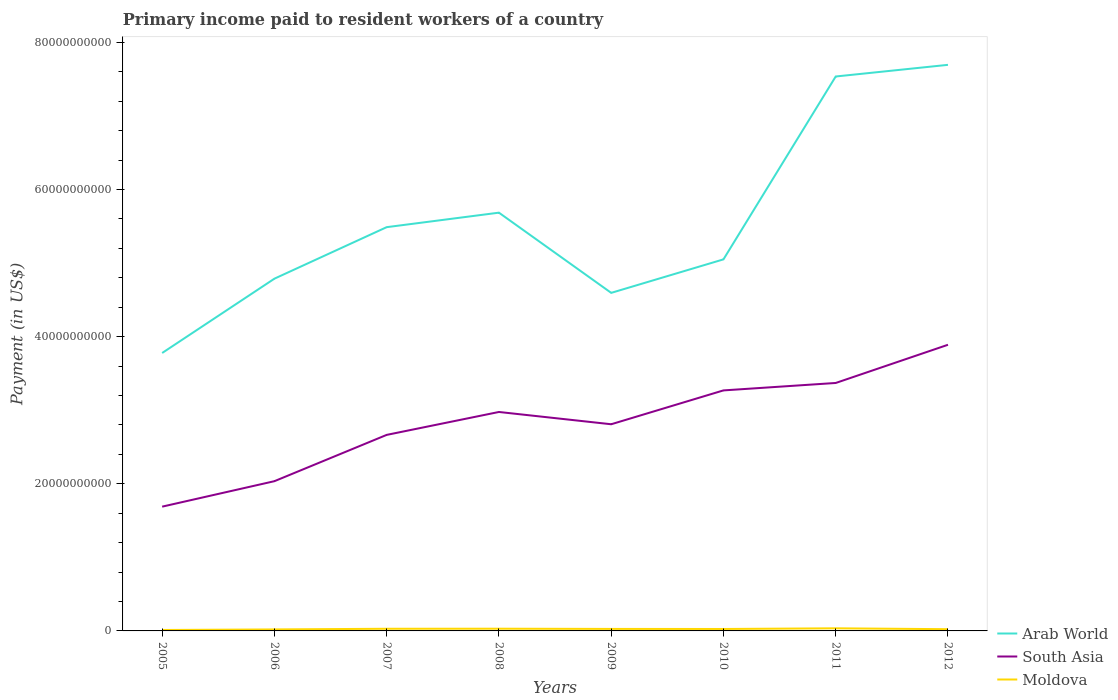Across all years, what is the maximum amount paid to workers in South Asia?
Your answer should be very brief. 1.69e+1. What is the total amount paid to workers in Moldova in the graph?
Offer a terse response. -1.65e+08. What is the difference between the highest and the second highest amount paid to workers in Arab World?
Ensure brevity in your answer.  3.92e+1. Is the amount paid to workers in Moldova strictly greater than the amount paid to workers in South Asia over the years?
Your answer should be very brief. Yes. How many lines are there?
Give a very brief answer. 3. Where does the legend appear in the graph?
Give a very brief answer. Bottom right. How many legend labels are there?
Offer a terse response. 3. What is the title of the graph?
Give a very brief answer. Primary income paid to resident workers of a country. Does "Senegal" appear as one of the legend labels in the graph?
Provide a succinct answer. No. What is the label or title of the Y-axis?
Make the answer very short. Payment (in US$). What is the Payment (in US$) of Arab World in 2005?
Provide a short and direct response. 3.78e+1. What is the Payment (in US$) in South Asia in 2005?
Provide a short and direct response. 1.69e+1. What is the Payment (in US$) of Moldova in 2005?
Your answer should be very brief. 1.28e+08. What is the Payment (in US$) of Arab World in 2006?
Provide a short and direct response. 4.79e+1. What is the Payment (in US$) in South Asia in 2006?
Your answer should be very brief. 2.04e+1. What is the Payment (in US$) of Moldova in 2006?
Give a very brief answer. 2.03e+08. What is the Payment (in US$) of Arab World in 2007?
Provide a succinct answer. 5.49e+1. What is the Payment (in US$) of South Asia in 2007?
Offer a terse response. 2.66e+1. What is the Payment (in US$) in Moldova in 2007?
Offer a terse response. 2.94e+08. What is the Payment (in US$) in Arab World in 2008?
Your response must be concise. 5.68e+1. What is the Payment (in US$) of South Asia in 2008?
Your response must be concise. 2.98e+1. What is the Payment (in US$) of Moldova in 2008?
Your answer should be compact. 3.01e+08. What is the Payment (in US$) of Arab World in 2009?
Your response must be concise. 4.59e+1. What is the Payment (in US$) in South Asia in 2009?
Your answer should be compact. 2.81e+1. What is the Payment (in US$) in Moldova in 2009?
Offer a terse response. 2.71e+08. What is the Payment (in US$) in Arab World in 2010?
Ensure brevity in your answer.  5.05e+1. What is the Payment (in US$) in South Asia in 2010?
Give a very brief answer. 3.27e+1. What is the Payment (in US$) of Moldova in 2010?
Keep it short and to the point. 2.62e+08. What is the Payment (in US$) in Arab World in 2011?
Offer a terse response. 7.54e+1. What is the Payment (in US$) in South Asia in 2011?
Ensure brevity in your answer.  3.37e+1. What is the Payment (in US$) of Moldova in 2011?
Offer a very short reply. 3.55e+08. What is the Payment (in US$) of Arab World in 2012?
Keep it short and to the point. 7.69e+1. What is the Payment (in US$) in South Asia in 2012?
Your response must be concise. 3.89e+1. What is the Payment (in US$) in Moldova in 2012?
Keep it short and to the point. 2.35e+08. Across all years, what is the maximum Payment (in US$) in Arab World?
Provide a short and direct response. 7.69e+1. Across all years, what is the maximum Payment (in US$) in South Asia?
Make the answer very short. 3.89e+1. Across all years, what is the maximum Payment (in US$) of Moldova?
Provide a succinct answer. 3.55e+08. Across all years, what is the minimum Payment (in US$) of Arab World?
Your response must be concise. 3.78e+1. Across all years, what is the minimum Payment (in US$) of South Asia?
Provide a short and direct response. 1.69e+1. Across all years, what is the minimum Payment (in US$) in Moldova?
Your answer should be compact. 1.28e+08. What is the total Payment (in US$) of Arab World in the graph?
Give a very brief answer. 4.46e+11. What is the total Payment (in US$) in South Asia in the graph?
Your answer should be very brief. 2.27e+11. What is the total Payment (in US$) in Moldova in the graph?
Give a very brief answer. 2.05e+09. What is the difference between the Payment (in US$) in Arab World in 2005 and that in 2006?
Offer a terse response. -1.01e+1. What is the difference between the Payment (in US$) in South Asia in 2005 and that in 2006?
Provide a succinct answer. -3.46e+09. What is the difference between the Payment (in US$) of Moldova in 2005 and that in 2006?
Make the answer very short. -7.50e+07. What is the difference between the Payment (in US$) of Arab World in 2005 and that in 2007?
Your answer should be very brief. -1.71e+1. What is the difference between the Payment (in US$) of South Asia in 2005 and that in 2007?
Provide a short and direct response. -9.75e+09. What is the difference between the Payment (in US$) of Moldova in 2005 and that in 2007?
Offer a terse response. -1.65e+08. What is the difference between the Payment (in US$) of Arab World in 2005 and that in 2008?
Give a very brief answer. -1.91e+1. What is the difference between the Payment (in US$) of South Asia in 2005 and that in 2008?
Keep it short and to the point. -1.29e+1. What is the difference between the Payment (in US$) in Moldova in 2005 and that in 2008?
Offer a terse response. -1.73e+08. What is the difference between the Payment (in US$) of Arab World in 2005 and that in 2009?
Your response must be concise. -8.17e+09. What is the difference between the Payment (in US$) in South Asia in 2005 and that in 2009?
Offer a terse response. -1.12e+1. What is the difference between the Payment (in US$) of Moldova in 2005 and that in 2009?
Your answer should be very brief. -1.42e+08. What is the difference between the Payment (in US$) in Arab World in 2005 and that in 2010?
Your answer should be very brief. -1.27e+1. What is the difference between the Payment (in US$) of South Asia in 2005 and that in 2010?
Offer a terse response. -1.58e+1. What is the difference between the Payment (in US$) in Moldova in 2005 and that in 2010?
Keep it short and to the point. -1.34e+08. What is the difference between the Payment (in US$) of Arab World in 2005 and that in 2011?
Provide a short and direct response. -3.76e+1. What is the difference between the Payment (in US$) of South Asia in 2005 and that in 2011?
Give a very brief answer. -1.68e+1. What is the difference between the Payment (in US$) in Moldova in 2005 and that in 2011?
Your answer should be compact. -2.27e+08. What is the difference between the Payment (in US$) of Arab World in 2005 and that in 2012?
Give a very brief answer. -3.92e+1. What is the difference between the Payment (in US$) of South Asia in 2005 and that in 2012?
Keep it short and to the point. -2.20e+1. What is the difference between the Payment (in US$) in Moldova in 2005 and that in 2012?
Provide a short and direct response. -1.07e+08. What is the difference between the Payment (in US$) of Arab World in 2006 and that in 2007?
Make the answer very short. -7.00e+09. What is the difference between the Payment (in US$) in South Asia in 2006 and that in 2007?
Your answer should be compact. -6.29e+09. What is the difference between the Payment (in US$) in Moldova in 2006 and that in 2007?
Make the answer very short. -9.03e+07. What is the difference between the Payment (in US$) of Arab World in 2006 and that in 2008?
Your answer should be compact. -8.97e+09. What is the difference between the Payment (in US$) of South Asia in 2006 and that in 2008?
Provide a succinct answer. -9.41e+09. What is the difference between the Payment (in US$) of Moldova in 2006 and that in 2008?
Provide a short and direct response. -9.80e+07. What is the difference between the Payment (in US$) of Arab World in 2006 and that in 2009?
Keep it short and to the point. 1.93e+09. What is the difference between the Payment (in US$) of South Asia in 2006 and that in 2009?
Provide a succinct answer. -7.74e+09. What is the difference between the Payment (in US$) of Moldova in 2006 and that in 2009?
Your answer should be compact. -6.74e+07. What is the difference between the Payment (in US$) in Arab World in 2006 and that in 2010?
Keep it short and to the point. -2.62e+09. What is the difference between the Payment (in US$) of South Asia in 2006 and that in 2010?
Provide a short and direct response. -1.23e+1. What is the difference between the Payment (in US$) of Moldova in 2006 and that in 2010?
Make the answer very short. -5.89e+07. What is the difference between the Payment (in US$) of Arab World in 2006 and that in 2011?
Your response must be concise. -2.75e+1. What is the difference between the Payment (in US$) of South Asia in 2006 and that in 2011?
Offer a very short reply. -1.33e+1. What is the difference between the Payment (in US$) of Moldova in 2006 and that in 2011?
Offer a very short reply. -1.52e+08. What is the difference between the Payment (in US$) of Arab World in 2006 and that in 2012?
Offer a very short reply. -2.91e+1. What is the difference between the Payment (in US$) in South Asia in 2006 and that in 2012?
Provide a succinct answer. -1.85e+1. What is the difference between the Payment (in US$) of Moldova in 2006 and that in 2012?
Give a very brief answer. -3.18e+07. What is the difference between the Payment (in US$) in Arab World in 2007 and that in 2008?
Ensure brevity in your answer.  -1.97e+09. What is the difference between the Payment (in US$) of South Asia in 2007 and that in 2008?
Keep it short and to the point. -3.11e+09. What is the difference between the Payment (in US$) of Moldova in 2007 and that in 2008?
Your answer should be compact. -7.77e+06. What is the difference between the Payment (in US$) of Arab World in 2007 and that in 2009?
Your answer should be very brief. 8.93e+09. What is the difference between the Payment (in US$) of South Asia in 2007 and that in 2009?
Ensure brevity in your answer.  -1.45e+09. What is the difference between the Payment (in US$) in Moldova in 2007 and that in 2009?
Ensure brevity in your answer.  2.28e+07. What is the difference between the Payment (in US$) of Arab World in 2007 and that in 2010?
Offer a very short reply. 4.38e+09. What is the difference between the Payment (in US$) in South Asia in 2007 and that in 2010?
Keep it short and to the point. -6.05e+09. What is the difference between the Payment (in US$) in Moldova in 2007 and that in 2010?
Provide a short and direct response. 3.14e+07. What is the difference between the Payment (in US$) in Arab World in 2007 and that in 2011?
Keep it short and to the point. -2.05e+1. What is the difference between the Payment (in US$) of South Asia in 2007 and that in 2011?
Ensure brevity in your answer.  -7.06e+09. What is the difference between the Payment (in US$) in Moldova in 2007 and that in 2011?
Ensure brevity in your answer.  -6.16e+07. What is the difference between the Payment (in US$) in Arab World in 2007 and that in 2012?
Your response must be concise. -2.21e+1. What is the difference between the Payment (in US$) in South Asia in 2007 and that in 2012?
Provide a succinct answer. -1.22e+1. What is the difference between the Payment (in US$) in Moldova in 2007 and that in 2012?
Your answer should be compact. 5.85e+07. What is the difference between the Payment (in US$) of Arab World in 2008 and that in 2009?
Your answer should be very brief. 1.09e+1. What is the difference between the Payment (in US$) of South Asia in 2008 and that in 2009?
Give a very brief answer. 1.67e+09. What is the difference between the Payment (in US$) of Moldova in 2008 and that in 2009?
Provide a short and direct response. 3.06e+07. What is the difference between the Payment (in US$) in Arab World in 2008 and that in 2010?
Provide a succinct answer. 6.35e+09. What is the difference between the Payment (in US$) of South Asia in 2008 and that in 2010?
Provide a short and direct response. -2.93e+09. What is the difference between the Payment (in US$) of Moldova in 2008 and that in 2010?
Make the answer very short. 3.92e+07. What is the difference between the Payment (in US$) of Arab World in 2008 and that in 2011?
Provide a short and direct response. -1.85e+1. What is the difference between the Payment (in US$) in South Asia in 2008 and that in 2011?
Give a very brief answer. -3.94e+09. What is the difference between the Payment (in US$) of Moldova in 2008 and that in 2011?
Offer a terse response. -5.38e+07. What is the difference between the Payment (in US$) of Arab World in 2008 and that in 2012?
Offer a very short reply. -2.01e+1. What is the difference between the Payment (in US$) of South Asia in 2008 and that in 2012?
Ensure brevity in your answer.  -9.13e+09. What is the difference between the Payment (in US$) of Moldova in 2008 and that in 2012?
Ensure brevity in your answer.  6.63e+07. What is the difference between the Payment (in US$) of Arab World in 2009 and that in 2010?
Keep it short and to the point. -4.55e+09. What is the difference between the Payment (in US$) in South Asia in 2009 and that in 2010?
Ensure brevity in your answer.  -4.60e+09. What is the difference between the Payment (in US$) in Moldova in 2009 and that in 2010?
Give a very brief answer. 8.54e+06. What is the difference between the Payment (in US$) in Arab World in 2009 and that in 2011?
Offer a terse response. -2.94e+1. What is the difference between the Payment (in US$) of South Asia in 2009 and that in 2011?
Your response must be concise. -5.61e+09. What is the difference between the Payment (in US$) in Moldova in 2009 and that in 2011?
Keep it short and to the point. -8.44e+07. What is the difference between the Payment (in US$) in Arab World in 2009 and that in 2012?
Make the answer very short. -3.10e+1. What is the difference between the Payment (in US$) in South Asia in 2009 and that in 2012?
Your answer should be compact. -1.08e+1. What is the difference between the Payment (in US$) of Moldova in 2009 and that in 2012?
Offer a very short reply. 3.57e+07. What is the difference between the Payment (in US$) in Arab World in 2010 and that in 2011?
Your answer should be compact. -2.49e+1. What is the difference between the Payment (in US$) of South Asia in 2010 and that in 2011?
Your response must be concise. -1.01e+09. What is the difference between the Payment (in US$) in Moldova in 2010 and that in 2011?
Provide a succinct answer. -9.30e+07. What is the difference between the Payment (in US$) in Arab World in 2010 and that in 2012?
Provide a short and direct response. -2.64e+1. What is the difference between the Payment (in US$) in South Asia in 2010 and that in 2012?
Keep it short and to the point. -6.20e+09. What is the difference between the Payment (in US$) of Moldova in 2010 and that in 2012?
Offer a very short reply. 2.72e+07. What is the difference between the Payment (in US$) in Arab World in 2011 and that in 2012?
Your answer should be very brief. -1.58e+09. What is the difference between the Payment (in US$) in South Asia in 2011 and that in 2012?
Keep it short and to the point. -5.19e+09. What is the difference between the Payment (in US$) in Moldova in 2011 and that in 2012?
Your response must be concise. 1.20e+08. What is the difference between the Payment (in US$) in Arab World in 2005 and the Payment (in US$) in South Asia in 2006?
Keep it short and to the point. 1.74e+1. What is the difference between the Payment (in US$) in Arab World in 2005 and the Payment (in US$) in Moldova in 2006?
Make the answer very short. 3.76e+1. What is the difference between the Payment (in US$) in South Asia in 2005 and the Payment (in US$) in Moldova in 2006?
Offer a terse response. 1.67e+1. What is the difference between the Payment (in US$) in Arab World in 2005 and the Payment (in US$) in South Asia in 2007?
Your response must be concise. 1.11e+1. What is the difference between the Payment (in US$) of Arab World in 2005 and the Payment (in US$) of Moldova in 2007?
Offer a very short reply. 3.75e+1. What is the difference between the Payment (in US$) of South Asia in 2005 and the Payment (in US$) of Moldova in 2007?
Provide a short and direct response. 1.66e+1. What is the difference between the Payment (in US$) in Arab World in 2005 and the Payment (in US$) in South Asia in 2008?
Offer a very short reply. 8.02e+09. What is the difference between the Payment (in US$) of Arab World in 2005 and the Payment (in US$) of Moldova in 2008?
Offer a terse response. 3.75e+1. What is the difference between the Payment (in US$) of South Asia in 2005 and the Payment (in US$) of Moldova in 2008?
Your answer should be very brief. 1.66e+1. What is the difference between the Payment (in US$) in Arab World in 2005 and the Payment (in US$) in South Asia in 2009?
Your response must be concise. 9.68e+09. What is the difference between the Payment (in US$) of Arab World in 2005 and the Payment (in US$) of Moldova in 2009?
Your response must be concise. 3.75e+1. What is the difference between the Payment (in US$) in South Asia in 2005 and the Payment (in US$) in Moldova in 2009?
Your answer should be compact. 1.66e+1. What is the difference between the Payment (in US$) of Arab World in 2005 and the Payment (in US$) of South Asia in 2010?
Provide a short and direct response. 5.08e+09. What is the difference between the Payment (in US$) of Arab World in 2005 and the Payment (in US$) of Moldova in 2010?
Give a very brief answer. 3.75e+1. What is the difference between the Payment (in US$) of South Asia in 2005 and the Payment (in US$) of Moldova in 2010?
Keep it short and to the point. 1.66e+1. What is the difference between the Payment (in US$) of Arab World in 2005 and the Payment (in US$) of South Asia in 2011?
Your answer should be very brief. 4.07e+09. What is the difference between the Payment (in US$) in Arab World in 2005 and the Payment (in US$) in Moldova in 2011?
Your answer should be compact. 3.74e+1. What is the difference between the Payment (in US$) in South Asia in 2005 and the Payment (in US$) in Moldova in 2011?
Provide a succinct answer. 1.65e+1. What is the difference between the Payment (in US$) of Arab World in 2005 and the Payment (in US$) of South Asia in 2012?
Make the answer very short. -1.12e+09. What is the difference between the Payment (in US$) of Arab World in 2005 and the Payment (in US$) of Moldova in 2012?
Provide a succinct answer. 3.75e+1. What is the difference between the Payment (in US$) in South Asia in 2005 and the Payment (in US$) in Moldova in 2012?
Offer a very short reply. 1.67e+1. What is the difference between the Payment (in US$) in Arab World in 2006 and the Payment (in US$) in South Asia in 2007?
Offer a terse response. 2.12e+1. What is the difference between the Payment (in US$) in Arab World in 2006 and the Payment (in US$) in Moldova in 2007?
Offer a very short reply. 4.76e+1. What is the difference between the Payment (in US$) in South Asia in 2006 and the Payment (in US$) in Moldova in 2007?
Keep it short and to the point. 2.01e+1. What is the difference between the Payment (in US$) in Arab World in 2006 and the Payment (in US$) in South Asia in 2008?
Provide a succinct answer. 1.81e+1. What is the difference between the Payment (in US$) of Arab World in 2006 and the Payment (in US$) of Moldova in 2008?
Make the answer very short. 4.76e+1. What is the difference between the Payment (in US$) of South Asia in 2006 and the Payment (in US$) of Moldova in 2008?
Offer a terse response. 2.00e+1. What is the difference between the Payment (in US$) in Arab World in 2006 and the Payment (in US$) in South Asia in 2009?
Your answer should be very brief. 1.98e+1. What is the difference between the Payment (in US$) in Arab World in 2006 and the Payment (in US$) in Moldova in 2009?
Keep it short and to the point. 4.76e+1. What is the difference between the Payment (in US$) of South Asia in 2006 and the Payment (in US$) of Moldova in 2009?
Offer a terse response. 2.01e+1. What is the difference between the Payment (in US$) of Arab World in 2006 and the Payment (in US$) of South Asia in 2010?
Your answer should be very brief. 1.52e+1. What is the difference between the Payment (in US$) of Arab World in 2006 and the Payment (in US$) of Moldova in 2010?
Keep it short and to the point. 4.76e+1. What is the difference between the Payment (in US$) in South Asia in 2006 and the Payment (in US$) in Moldova in 2010?
Keep it short and to the point. 2.01e+1. What is the difference between the Payment (in US$) of Arab World in 2006 and the Payment (in US$) of South Asia in 2011?
Provide a short and direct response. 1.42e+1. What is the difference between the Payment (in US$) in Arab World in 2006 and the Payment (in US$) in Moldova in 2011?
Your answer should be very brief. 4.75e+1. What is the difference between the Payment (in US$) of South Asia in 2006 and the Payment (in US$) of Moldova in 2011?
Keep it short and to the point. 2.00e+1. What is the difference between the Payment (in US$) in Arab World in 2006 and the Payment (in US$) in South Asia in 2012?
Your answer should be compact. 8.98e+09. What is the difference between the Payment (in US$) of Arab World in 2006 and the Payment (in US$) of Moldova in 2012?
Ensure brevity in your answer.  4.76e+1. What is the difference between the Payment (in US$) of South Asia in 2006 and the Payment (in US$) of Moldova in 2012?
Provide a succinct answer. 2.01e+1. What is the difference between the Payment (in US$) in Arab World in 2007 and the Payment (in US$) in South Asia in 2008?
Provide a short and direct response. 2.51e+1. What is the difference between the Payment (in US$) in Arab World in 2007 and the Payment (in US$) in Moldova in 2008?
Your response must be concise. 5.46e+1. What is the difference between the Payment (in US$) of South Asia in 2007 and the Payment (in US$) of Moldova in 2008?
Your answer should be compact. 2.63e+1. What is the difference between the Payment (in US$) in Arab World in 2007 and the Payment (in US$) in South Asia in 2009?
Offer a very short reply. 2.68e+1. What is the difference between the Payment (in US$) in Arab World in 2007 and the Payment (in US$) in Moldova in 2009?
Provide a short and direct response. 5.46e+1. What is the difference between the Payment (in US$) of South Asia in 2007 and the Payment (in US$) of Moldova in 2009?
Keep it short and to the point. 2.64e+1. What is the difference between the Payment (in US$) of Arab World in 2007 and the Payment (in US$) of South Asia in 2010?
Make the answer very short. 2.22e+1. What is the difference between the Payment (in US$) of Arab World in 2007 and the Payment (in US$) of Moldova in 2010?
Your answer should be very brief. 5.46e+1. What is the difference between the Payment (in US$) of South Asia in 2007 and the Payment (in US$) of Moldova in 2010?
Your answer should be very brief. 2.64e+1. What is the difference between the Payment (in US$) in Arab World in 2007 and the Payment (in US$) in South Asia in 2011?
Provide a succinct answer. 2.12e+1. What is the difference between the Payment (in US$) in Arab World in 2007 and the Payment (in US$) in Moldova in 2011?
Ensure brevity in your answer.  5.45e+1. What is the difference between the Payment (in US$) of South Asia in 2007 and the Payment (in US$) of Moldova in 2011?
Ensure brevity in your answer.  2.63e+1. What is the difference between the Payment (in US$) in Arab World in 2007 and the Payment (in US$) in South Asia in 2012?
Ensure brevity in your answer.  1.60e+1. What is the difference between the Payment (in US$) of Arab World in 2007 and the Payment (in US$) of Moldova in 2012?
Keep it short and to the point. 5.46e+1. What is the difference between the Payment (in US$) of South Asia in 2007 and the Payment (in US$) of Moldova in 2012?
Give a very brief answer. 2.64e+1. What is the difference between the Payment (in US$) of Arab World in 2008 and the Payment (in US$) of South Asia in 2009?
Ensure brevity in your answer.  2.88e+1. What is the difference between the Payment (in US$) in Arab World in 2008 and the Payment (in US$) in Moldova in 2009?
Offer a terse response. 5.66e+1. What is the difference between the Payment (in US$) in South Asia in 2008 and the Payment (in US$) in Moldova in 2009?
Ensure brevity in your answer.  2.95e+1. What is the difference between the Payment (in US$) of Arab World in 2008 and the Payment (in US$) of South Asia in 2010?
Your response must be concise. 2.42e+1. What is the difference between the Payment (in US$) of Arab World in 2008 and the Payment (in US$) of Moldova in 2010?
Offer a very short reply. 5.66e+1. What is the difference between the Payment (in US$) of South Asia in 2008 and the Payment (in US$) of Moldova in 2010?
Your answer should be compact. 2.95e+1. What is the difference between the Payment (in US$) of Arab World in 2008 and the Payment (in US$) of South Asia in 2011?
Your response must be concise. 2.31e+1. What is the difference between the Payment (in US$) of Arab World in 2008 and the Payment (in US$) of Moldova in 2011?
Offer a terse response. 5.65e+1. What is the difference between the Payment (in US$) of South Asia in 2008 and the Payment (in US$) of Moldova in 2011?
Make the answer very short. 2.94e+1. What is the difference between the Payment (in US$) of Arab World in 2008 and the Payment (in US$) of South Asia in 2012?
Your answer should be compact. 1.80e+1. What is the difference between the Payment (in US$) in Arab World in 2008 and the Payment (in US$) in Moldova in 2012?
Your answer should be compact. 5.66e+1. What is the difference between the Payment (in US$) in South Asia in 2008 and the Payment (in US$) in Moldova in 2012?
Offer a very short reply. 2.95e+1. What is the difference between the Payment (in US$) in Arab World in 2009 and the Payment (in US$) in South Asia in 2010?
Give a very brief answer. 1.33e+1. What is the difference between the Payment (in US$) of Arab World in 2009 and the Payment (in US$) of Moldova in 2010?
Give a very brief answer. 4.57e+1. What is the difference between the Payment (in US$) of South Asia in 2009 and the Payment (in US$) of Moldova in 2010?
Give a very brief answer. 2.78e+1. What is the difference between the Payment (in US$) in Arab World in 2009 and the Payment (in US$) in South Asia in 2011?
Provide a short and direct response. 1.22e+1. What is the difference between the Payment (in US$) in Arab World in 2009 and the Payment (in US$) in Moldova in 2011?
Your response must be concise. 4.56e+1. What is the difference between the Payment (in US$) in South Asia in 2009 and the Payment (in US$) in Moldova in 2011?
Provide a succinct answer. 2.77e+1. What is the difference between the Payment (in US$) in Arab World in 2009 and the Payment (in US$) in South Asia in 2012?
Keep it short and to the point. 7.05e+09. What is the difference between the Payment (in US$) in Arab World in 2009 and the Payment (in US$) in Moldova in 2012?
Your response must be concise. 4.57e+1. What is the difference between the Payment (in US$) of South Asia in 2009 and the Payment (in US$) of Moldova in 2012?
Keep it short and to the point. 2.79e+1. What is the difference between the Payment (in US$) of Arab World in 2010 and the Payment (in US$) of South Asia in 2011?
Keep it short and to the point. 1.68e+1. What is the difference between the Payment (in US$) of Arab World in 2010 and the Payment (in US$) of Moldova in 2011?
Your answer should be very brief. 5.01e+1. What is the difference between the Payment (in US$) of South Asia in 2010 and the Payment (in US$) of Moldova in 2011?
Give a very brief answer. 3.23e+1. What is the difference between the Payment (in US$) of Arab World in 2010 and the Payment (in US$) of South Asia in 2012?
Your answer should be very brief. 1.16e+1. What is the difference between the Payment (in US$) in Arab World in 2010 and the Payment (in US$) in Moldova in 2012?
Offer a terse response. 5.03e+1. What is the difference between the Payment (in US$) of South Asia in 2010 and the Payment (in US$) of Moldova in 2012?
Give a very brief answer. 3.25e+1. What is the difference between the Payment (in US$) in Arab World in 2011 and the Payment (in US$) in South Asia in 2012?
Make the answer very short. 3.65e+1. What is the difference between the Payment (in US$) of Arab World in 2011 and the Payment (in US$) of Moldova in 2012?
Provide a succinct answer. 7.51e+1. What is the difference between the Payment (in US$) in South Asia in 2011 and the Payment (in US$) in Moldova in 2012?
Provide a succinct answer. 3.35e+1. What is the average Payment (in US$) of Arab World per year?
Offer a very short reply. 5.58e+1. What is the average Payment (in US$) of South Asia per year?
Provide a short and direct response. 2.84e+1. What is the average Payment (in US$) in Moldova per year?
Give a very brief answer. 2.56e+08. In the year 2005, what is the difference between the Payment (in US$) of Arab World and Payment (in US$) of South Asia?
Give a very brief answer. 2.09e+1. In the year 2005, what is the difference between the Payment (in US$) of Arab World and Payment (in US$) of Moldova?
Your response must be concise. 3.76e+1. In the year 2005, what is the difference between the Payment (in US$) of South Asia and Payment (in US$) of Moldova?
Give a very brief answer. 1.68e+1. In the year 2006, what is the difference between the Payment (in US$) of Arab World and Payment (in US$) of South Asia?
Make the answer very short. 2.75e+1. In the year 2006, what is the difference between the Payment (in US$) in Arab World and Payment (in US$) in Moldova?
Keep it short and to the point. 4.77e+1. In the year 2006, what is the difference between the Payment (in US$) of South Asia and Payment (in US$) of Moldova?
Make the answer very short. 2.01e+1. In the year 2007, what is the difference between the Payment (in US$) of Arab World and Payment (in US$) of South Asia?
Your answer should be very brief. 2.82e+1. In the year 2007, what is the difference between the Payment (in US$) of Arab World and Payment (in US$) of Moldova?
Offer a very short reply. 5.46e+1. In the year 2007, what is the difference between the Payment (in US$) of South Asia and Payment (in US$) of Moldova?
Keep it short and to the point. 2.63e+1. In the year 2008, what is the difference between the Payment (in US$) in Arab World and Payment (in US$) in South Asia?
Keep it short and to the point. 2.71e+1. In the year 2008, what is the difference between the Payment (in US$) of Arab World and Payment (in US$) of Moldova?
Your answer should be very brief. 5.65e+1. In the year 2008, what is the difference between the Payment (in US$) of South Asia and Payment (in US$) of Moldova?
Your response must be concise. 2.95e+1. In the year 2009, what is the difference between the Payment (in US$) in Arab World and Payment (in US$) in South Asia?
Provide a short and direct response. 1.79e+1. In the year 2009, what is the difference between the Payment (in US$) of Arab World and Payment (in US$) of Moldova?
Give a very brief answer. 4.57e+1. In the year 2009, what is the difference between the Payment (in US$) in South Asia and Payment (in US$) in Moldova?
Give a very brief answer. 2.78e+1. In the year 2010, what is the difference between the Payment (in US$) in Arab World and Payment (in US$) in South Asia?
Provide a short and direct response. 1.78e+1. In the year 2010, what is the difference between the Payment (in US$) of Arab World and Payment (in US$) of Moldova?
Make the answer very short. 5.02e+1. In the year 2010, what is the difference between the Payment (in US$) in South Asia and Payment (in US$) in Moldova?
Your answer should be compact. 3.24e+1. In the year 2011, what is the difference between the Payment (in US$) in Arab World and Payment (in US$) in South Asia?
Your answer should be very brief. 4.17e+1. In the year 2011, what is the difference between the Payment (in US$) in Arab World and Payment (in US$) in Moldova?
Your response must be concise. 7.50e+1. In the year 2011, what is the difference between the Payment (in US$) in South Asia and Payment (in US$) in Moldova?
Ensure brevity in your answer.  3.33e+1. In the year 2012, what is the difference between the Payment (in US$) of Arab World and Payment (in US$) of South Asia?
Provide a short and direct response. 3.80e+1. In the year 2012, what is the difference between the Payment (in US$) in Arab World and Payment (in US$) in Moldova?
Provide a succinct answer. 7.67e+1. In the year 2012, what is the difference between the Payment (in US$) of South Asia and Payment (in US$) of Moldova?
Your answer should be compact. 3.87e+1. What is the ratio of the Payment (in US$) in Arab World in 2005 to that in 2006?
Your answer should be very brief. 0.79. What is the ratio of the Payment (in US$) in South Asia in 2005 to that in 2006?
Give a very brief answer. 0.83. What is the ratio of the Payment (in US$) in Moldova in 2005 to that in 2006?
Your answer should be compact. 0.63. What is the ratio of the Payment (in US$) in Arab World in 2005 to that in 2007?
Provide a succinct answer. 0.69. What is the ratio of the Payment (in US$) of South Asia in 2005 to that in 2007?
Ensure brevity in your answer.  0.63. What is the ratio of the Payment (in US$) in Moldova in 2005 to that in 2007?
Make the answer very short. 0.44. What is the ratio of the Payment (in US$) of Arab World in 2005 to that in 2008?
Give a very brief answer. 0.66. What is the ratio of the Payment (in US$) of South Asia in 2005 to that in 2008?
Your answer should be compact. 0.57. What is the ratio of the Payment (in US$) in Moldova in 2005 to that in 2008?
Your answer should be compact. 0.43. What is the ratio of the Payment (in US$) of Arab World in 2005 to that in 2009?
Offer a very short reply. 0.82. What is the ratio of the Payment (in US$) in South Asia in 2005 to that in 2009?
Your answer should be compact. 0.6. What is the ratio of the Payment (in US$) in Moldova in 2005 to that in 2009?
Provide a succinct answer. 0.47. What is the ratio of the Payment (in US$) in Arab World in 2005 to that in 2010?
Your answer should be very brief. 0.75. What is the ratio of the Payment (in US$) of South Asia in 2005 to that in 2010?
Ensure brevity in your answer.  0.52. What is the ratio of the Payment (in US$) in Moldova in 2005 to that in 2010?
Make the answer very short. 0.49. What is the ratio of the Payment (in US$) of Arab World in 2005 to that in 2011?
Give a very brief answer. 0.5. What is the ratio of the Payment (in US$) in South Asia in 2005 to that in 2011?
Your response must be concise. 0.5. What is the ratio of the Payment (in US$) of Moldova in 2005 to that in 2011?
Keep it short and to the point. 0.36. What is the ratio of the Payment (in US$) of Arab World in 2005 to that in 2012?
Offer a very short reply. 0.49. What is the ratio of the Payment (in US$) of South Asia in 2005 to that in 2012?
Keep it short and to the point. 0.43. What is the ratio of the Payment (in US$) of Moldova in 2005 to that in 2012?
Provide a short and direct response. 0.55. What is the ratio of the Payment (in US$) of Arab World in 2006 to that in 2007?
Provide a short and direct response. 0.87. What is the ratio of the Payment (in US$) of South Asia in 2006 to that in 2007?
Provide a succinct answer. 0.76. What is the ratio of the Payment (in US$) in Moldova in 2006 to that in 2007?
Your response must be concise. 0.69. What is the ratio of the Payment (in US$) of Arab World in 2006 to that in 2008?
Ensure brevity in your answer.  0.84. What is the ratio of the Payment (in US$) of South Asia in 2006 to that in 2008?
Offer a terse response. 0.68. What is the ratio of the Payment (in US$) in Moldova in 2006 to that in 2008?
Your answer should be compact. 0.67. What is the ratio of the Payment (in US$) in Arab World in 2006 to that in 2009?
Provide a succinct answer. 1.04. What is the ratio of the Payment (in US$) of South Asia in 2006 to that in 2009?
Provide a succinct answer. 0.72. What is the ratio of the Payment (in US$) of Moldova in 2006 to that in 2009?
Offer a very short reply. 0.75. What is the ratio of the Payment (in US$) of Arab World in 2006 to that in 2010?
Offer a very short reply. 0.95. What is the ratio of the Payment (in US$) in South Asia in 2006 to that in 2010?
Provide a short and direct response. 0.62. What is the ratio of the Payment (in US$) of Moldova in 2006 to that in 2010?
Keep it short and to the point. 0.78. What is the ratio of the Payment (in US$) of Arab World in 2006 to that in 2011?
Provide a succinct answer. 0.64. What is the ratio of the Payment (in US$) in South Asia in 2006 to that in 2011?
Your answer should be very brief. 0.6. What is the ratio of the Payment (in US$) in Moldova in 2006 to that in 2011?
Your answer should be very brief. 0.57. What is the ratio of the Payment (in US$) of Arab World in 2006 to that in 2012?
Ensure brevity in your answer.  0.62. What is the ratio of the Payment (in US$) in South Asia in 2006 to that in 2012?
Give a very brief answer. 0.52. What is the ratio of the Payment (in US$) of Moldova in 2006 to that in 2012?
Keep it short and to the point. 0.86. What is the ratio of the Payment (in US$) in Arab World in 2007 to that in 2008?
Offer a terse response. 0.97. What is the ratio of the Payment (in US$) in South Asia in 2007 to that in 2008?
Offer a very short reply. 0.9. What is the ratio of the Payment (in US$) in Moldova in 2007 to that in 2008?
Provide a short and direct response. 0.97. What is the ratio of the Payment (in US$) in Arab World in 2007 to that in 2009?
Give a very brief answer. 1.19. What is the ratio of the Payment (in US$) of South Asia in 2007 to that in 2009?
Ensure brevity in your answer.  0.95. What is the ratio of the Payment (in US$) of Moldova in 2007 to that in 2009?
Offer a terse response. 1.08. What is the ratio of the Payment (in US$) of Arab World in 2007 to that in 2010?
Provide a short and direct response. 1.09. What is the ratio of the Payment (in US$) of South Asia in 2007 to that in 2010?
Your answer should be very brief. 0.81. What is the ratio of the Payment (in US$) of Moldova in 2007 to that in 2010?
Your answer should be very brief. 1.12. What is the ratio of the Payment (in US$) of Arab World in 2007 to that in 2011?
Your answer should be compact. 0.73. What is the ratio of the Payment (in US$) of South Asia in 2007 to that in 2011?
Your answer should be compact. 0.79. What is the ratio of the Payment (in US$) in Moldova in 2007 to that in 2011?
Keep it short and to the point. 0.83. What is the ratio of the Payment (in US$) in Arab World in 2007 to that in 2012?
Your answer should be compact. 0.71. What is the ratio of the Payment (in US$) in South Asia in 2007 to that in 2012?
Keep it short and to the point. 0.69. What is the ratio of the Payment (in US$) in Moldova in 2007 to that in 2012?
Offer a very short reply. 1.25. What is the ratio of the Payment (in US$) of Arab World in 2008 to that in 2009?
Make the answer very short. 1.24. What is the ratio of the Payment (in US$) of South Asia in 2008 to that in 2009?
Your response must be concise. 1.06. What is the ratio of the Payment (in US$) in Moldova in 2008 to that in 2009?
Make the answer very short. 1.11. What is the ratio of the Payment (in US$) in Arab World in 2008 to that in 2010?
Your answer should be very brief. 1.13. What is the ratio of the Payment (in US$) in South Asia in 2008 to that in 2010?
Ensure brevity in your answer.  0.91. What is the ratio of the Payment (in US$) of Moldova in 2008 to that in 2010?
Provide a succinct answer. 1.15. What is the ratio of the Payment (in US$) in Arab World in 2008 to that in 2011?
Your answer should be very brief. 0.75. What is the ratio of the Payment (in US$) in South Asia in 2008 to that in 2011?
Give a very brief answer. 0.88. What is the ratio of the Payment (in US$) in Moldova in 2008 to that in 2011?
Your answer should be compact. 0.85. What is the ratio of the Payment (in US$) in Arab World in 2008 to that in 2012?
Your answer should be very brief. 0.74. What is the ratio of the Payment (in US$) in South Asia in 2008 to that in 2012?
Offer a terse response. 0.77. What is the ratio of the Payment (in US$) of Moldova in 2008 to that in 2012?
Offer a terse response. 1.28. What is the ratio of the Payment (in US$) of Arab World in 2009 to that in 2010?
Ensure brevity in your answer.  0.91. What is the ratio of the Payment (in US$) in South Asia in 2009 to that in 2010?
Offer a very short reply. 0.86. What is the ratio of the Payment (in US$) of Moldova in 2009 to that in 2010?
Make the answer very short. 1.03. What is the ratio of the Payment (in US$) in Arab World in 2009 to that in 2011?
Your answer should be very brief. 0.61. What is the ratio of the Payment (in US$) in South Asia in 2009 to that in 2011?
Your answer should be very brief. 0.83. What is the ratio of the Payment (in US$) in Moldova in 2009 to that in 2011?
Offer a very short reply. 0.76. What is the ratio of the Payment (in US$) in Arab World in 2009 to that in 2012?
Make the answer very short. 0.6. What is the ratio of the Payment (in US$) in South Asia in 2009 to that in 2012?
Your response must be concise. 0.72. What is the ratio of the Payment (in US$) in Moldova in 2009 to that in 2012?
Provide a short and direct response. 1.15. What is the ratio of the Payment (in US$) in Arab World in 2010 to that in 2011?
Offer a very short reply. 0.67. What is the ratio of the Payment (in US$) of Moldova in 2010 to that in 2011?
Keep it short and to the point. 0.74. What is the ratio of the Payment (in US$) in Arab World in 2010 to that in 2012?
Provide a succinct answer. 0.66. What is the ratio of the Payment (in US$) in South Asia in 2010 to that in 2012?
Your answer should be very brief. 0.84. What is the ratio of the Payment (in US$) in Moldova in 2010 to that in 2012?
Make the answer very short. 1.12. What is the ratio of the Payment (in US$) in Arab World in 2011 to that in 2012?
Provide a succinct answer. 0.98. What is the ratio of the Payment (in US$) of South Asia in 2011 to that in 2012?
Offer a very short reply. 0.87. What is the ratio of the Payment (in US$) in Moldova in 2011 to that in 2012?
Offer a very short reply. 1.51. What is the difference between the highest and the second highest Payment (in US$) of Arab World?
Your response must be concise. 1.58e+09. What is the difference between the highest and the second highest Payment (in US$) of South Asia?
Ensure brevity in your answer.  5.19e+09. What is the difference between the highest and the second highest Payment (in US$) of Moldova?
Keep it short and to the point. 5.38e+07. What is the difference between the highest and the lowest Payment (in US$) of Arab World?
Ensure brevity in your answer.  3.92e+1. What is the difference between the highest and the lowest Payment (in US$) of South Asia?
Keep it short and to the point. 2.20e+1. What is the difference between the highest and the lowest Payment (in US$) of Moldova?
Give a very brief answer. 2.27e+08. 